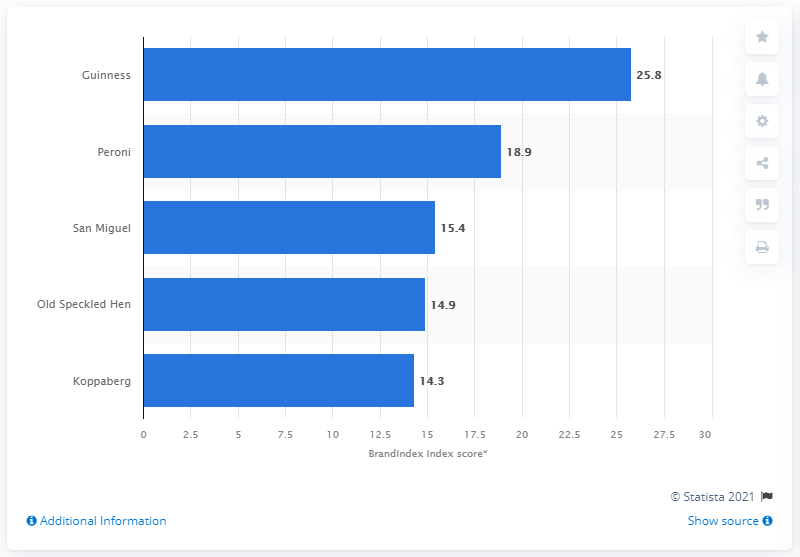Identify some key points in this picture. Guinness's score from July 1, 2018 to June 30, 2019 was 25.8. 